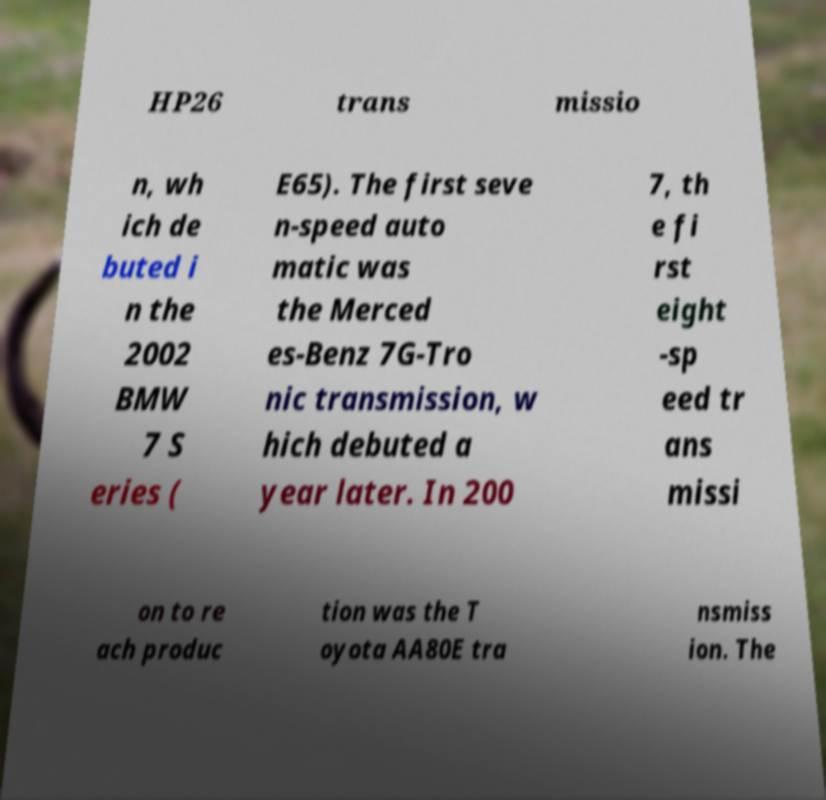What messages or text are displayed in this image? I need them in a readable, typed format. HP26 trans missio n, wh ich de buted i n the 2002 BMW 7 S eries ( E65). The first seve n-speed auto matic was the Merced es-Benz 7G-Tro nic transmission, w hich debuted a year later. In 200 7, th e fi rst eight -sp eed tr ans missi on to re ach produc tion was the T oyota AA80E tra nsmiss ion. The 